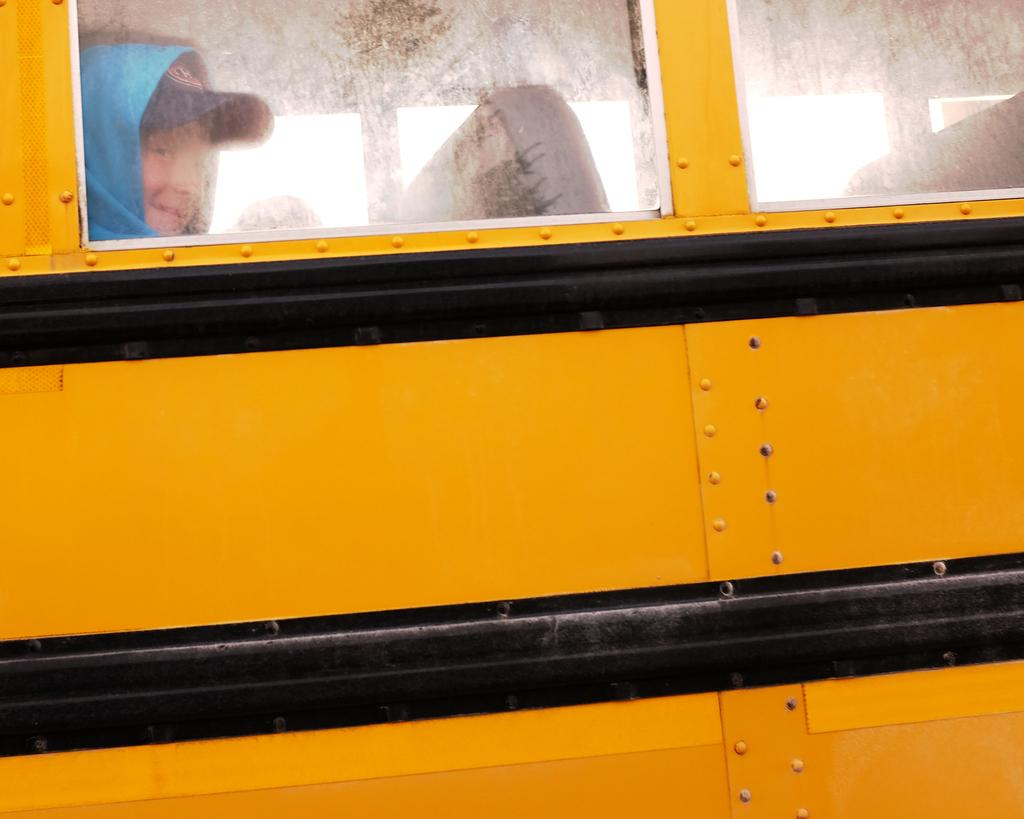What is the main subject of the image? The main subject of the image is a vehicle. How is the vehicle depicted in the image? The vehicle appears to be truncated. Can you describe the person visible through the windows of the vehicle? Unfortunately, the image does not provide enough detail to describe the person. What can be found inside the vehicle? Seats are present inside the vehicle. What type of texture can be seen on the teaching materials in the image? There are no teaching materials present in the image, so it is not possible to determine the texture of any such materials. 